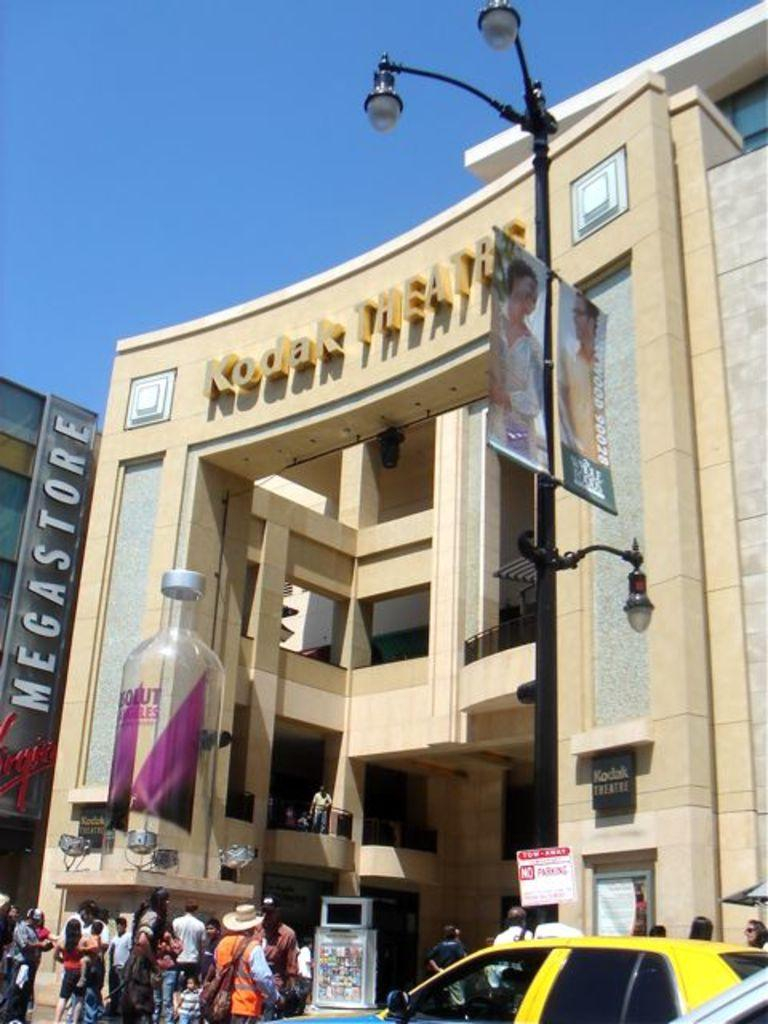<image>
Create a compact narrative representing the image presented. The front of the Kodak Theater in the middle of a sunny day. 